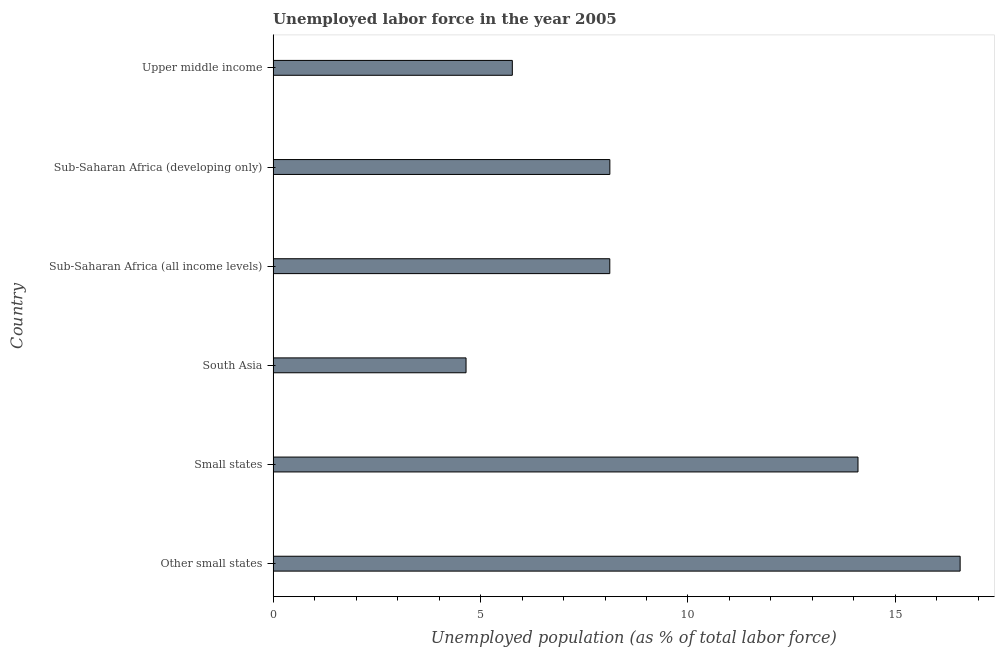Does the graph contain any zero values?
Offer a terse response. No. What is the title of the graph?
Make the answer very short. Unemployed labor force in the year 2005. What is the label or title of the X-axis?
Offer a terse response. Unemployed population (as % of total labor force). What is the total unemployed population in Sub-Saharan Africa (developing only)?
Provide a short and direct response. 8.12. Across all countries, what is the maximum total unemployed population?
Ensure brevity in your answer.  16.56. Across all countries, what is the minimum total unemployed population?
Your answer should be compact. 4.65. In which country was the total unemployed population maximum?
Offer a very short reply. Other small states. In which country was the total unemployed population minimum?
Provide a short and direct response. South Asia. What is the sum of the total unemployed population?
Give a very brief answer. 57.31. What is the difference between the total unemployed population in Other small states and Upper middle income?
Give a very brief answer. 10.79. What is the average total unemployed population per country?
Ensure brevity in your answer.  9.55. What is the median total unemployed population?
Provide a short and direct response. 8.12. In how many countries, is the total unemployed population greater than 2 %?
Your answer should be compact. 6. What is the ratio of the total unemployed population in Sub-Saharan Africa (all income levels) to that in Upper middle income?
Your answer should be compact. 1.41. Is the total unemployed population in South Asia less than that in Upper middle income?
Provide a short and direct response. Yes. Is the difference between the total unemployed population in South Asia and Upper middle income greater than the difference between any two countries?
Provide a short and direct response. No. What is the difference between the highest and the second highest total unemployed population?
Offer a very short reply. 2.46. What is the difference between the highest and the lowest total unemployed population?
Give a very brief answer. 11.91. How many bars are there?
Provide a short and direct response. 6. What is the Unemployed population (as % of total labor force) of Other small states?
Make the answer very short. 16.56. What is the Unemployed population (as % of total labor force) of Small states?
Offer a very short reply. 14.1. What is the Unemployed population (as % of total labor force) of South Asia?
Your response must be concise. 4.65. What is the Unemployed population (as % of total labor force) of Sub-Saharan Africa (all income levels)?
Make the answer very short. 8.12. What is the Unemployed population (as % of total labor force) of Sub-Saharan Africa (developing only)?
Keep it short and to the point. 8.12. What is the Unemployed population (as % of total labor force) in Upper middle income?
Make the answer very short. 5.77. What is the difference between the Unemployed population (as % of total labor force) in Other small states and Small states?
Your answer should be compact. 2.46. What is the difference between the Unemployed population (as % of total labor force) in Other small states and South Asia?
Your answer should be compact. 11.91. What is the difference between the Unemployed population (as % of total labor force) in Other small states and Sub-Saharan Africa (all income levels)?
Give a very brief answer. 8.45. What is the difference between the Unemployed population (as % of total labor force) in Other small states and Sub-Saharan Africa (developing only)?
Your response must be concise. 8.44. What is the difference between the Unemployed population (as % of total labor force) in Other small states and Upper middle income?
Give a very brief answer. 10.79. What is the difference between the Unemployed population (as % of total labor force) in Small states and South Asia?
Your answer should be very brief. 9.45. What is the difference between the Unemployed population (as % of total labor force) in Small states and Sub-Saharan Africa (all income levels)?
Ensure brevity in your answer.  5.98. What is the difference between the Unemployed population (as % of total labor force) in Small states and Sub-Saharan Africa (developing only)?
Ensure brevity in your answer.  5.98. What is the difference between the Unemployed population (as % of total labor force) in Small states and Upper middle income?
Ensure brevity in your answer.  8.33. What is the difference between the Unemployed population (as % of total labor force) in South Asia and Sub-Saharan Africa (all income levels)?
Your answer should be compact. -3.47. What is the difference between the Unemployed population (as % of total labor force) in South Asia and Sub-Saharan Africa (developing only)?
Your answer should be compact. -3.47. What is the difference between the Unemployed population (as % of total labor force) in South Asia and Upper middle income?
Keep it short and to the point. -1.12. What is the difference between the Unemployed population (as % of total labor force) in Sub-Saharan Africa (all income levels) and Sub-Saharan Africa (developing only)?
Your answer should be compact. -0. What is the difference between the Unemployed population (as % of total labor force) in Sub-Saharan Africa (all income levels) and Upper middle income?
Keep it short and to the point. 2.35. What is the difference between the Unemployed population (as % of total labor force) in Sub-Saharan Africa (developing only) and Upper middle income?
Your answer should be compact. 2.35. What is the ratio of the Unemployed population (as % of total labor force) in Other small states to that in Small states?
Keep it short and to the point. 1.18. What is the ratio of the Unemployed population (as % of total labor force) in Other small states to that in South Asia?
Offer a very short reply. 3.56. What is the ratio of the Unemployed population (as % of total labor force) in Other small states to that in Sub-Saharan Africa (all income levels)?
Your answer should be very brief. 2.04. What is the ratio of the Unemployed population (as % of total labor force) in Other small states to that in Sub-Saharan Africa (developing only)?
Offer a very short reply. 2.04. What is the ratio of the Unemployed population (as % of total labor force) in Other small states to that in Upper middle income?
Keep it short and to the point. 2.87. What is the ratio of the Unemployed population (as % of total labor force) in Small states to that in South Asia?
Make the answer very short. 3.03. What is the ratio of the Unemployed population (as % of total labor force) in Small states to that in Sub-Saharan Africa (all income levels)?
Offer a very short reply. 1.74. What is the ratio of the Unemployed population (as % of total labor force) in Small states to that in Sub-Saharan Africa (developing only)?
Provide a short and direct response. 1.74. What is the ratio of the Unemployed population (as % of total labor force) in Small states to that in Upper middle income?
Your answer should be compact. 2.44. What is the ratio of the Unemployed population (as % of total labor force) in South Asia to that in Sub-Saharan Africa (all income levels)?
Keep it short and to the point. 0.57. What is the ratio of the Unemployed population (as % of total labor force) in South Asia to that in Sub-Saharan Africa (developing only)?
Offer a terse response. 0.57. What is the ratio of the Unemployed population (as % of total labor force) in South Asia to that in Upper middle income?
Give a very brief answer. 0.81. What is the ratio of the Unemployed population (as % of total labor force) in Sub-Saharan Africa (all income levels) to that in Upper middle income?
Ensure brevity in your answer.  1.41. What is the ratio of the Unemployed population (as % of total labor force) in Sub-Saharan Africa (developing only) to that in Upper middle income?
Give a very brief answer. 1.41. 